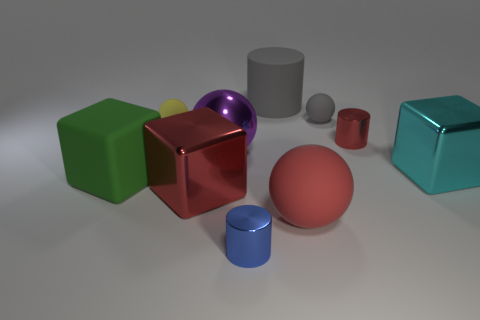Do the rubber cylinder and the big sphere right of the big purple thing have the same color? no 